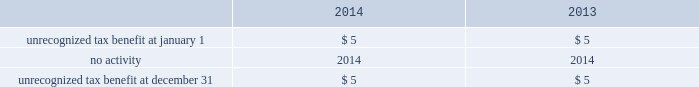Table of contents notes to consolidated financial statements of american airlines , inc .
American files its tax returns as prescribed by the tax laws of the jurisdictions in which it operates .
American 2019s 2004 through 2013 tax years are still subject to examination by the internal revenue service .
Various state and foreign jurisdiction tax years remain open to examination and american is under examination , in administrative appeals , or engaged in tax litigation in certain jurisdictions .
American believes that the effect of additional assessments will be immaterial to its consolidated financial statements .
American has an unrecognized tax benefit of approximately $ 5 million , which did not change during the twelve months ended december 31 , 2014 .
Changes in the unrecognized tax benefit have no impact on the effective tax rate due to the existence of the valuation allowance .
Accrued interest on tax positions is recorded as a component of interest expense but was not significant at december 31 , 2014 .
The reconciliation of the beginning and ending amounts of unrecognized tax benefit are ( in millions ) : .
American estimates that the unrecognized tax benefit will be realized within the next twelve months .
Risk management and financial instruments american 2019s economic prospects are heavily dependent upon two variables it cannot control : the health of the economy and the price of fuel .
Due to the discretionary nature of business and leisure travel spending , airline industry revenues are heavily influenced by the condition of the u.s .
Economy and economies in other regions of the world .
Unfavorable conditions in these broader economies have resulted , and may result in the future , in decreased passenger demand for air travel and changes in booking practices , both of which in turn have had , and may have in the future , a strong negative effect on american 2019s revenues .
In addition , during challenging economic times , actions by our competitors to increase their revenues can have an adverse impact on american 2019s revenues .
American 2019s operating results are materially impacted by changes in the availability , price volatility and cost of aircraft fuel , which represents one of the largest single cost items in american 2019s business .
Because of the amount of fuel needed to operate american 2019s business , even a relatively small increase in the price of fuel can have a material adverse aggregate effect on american 2019s operating results and liquidity .
Jet fuel market prices have fluctuated substantially over the past several years and prices continued to be volatile in 2014 .
These factors could impact american 2019s results of operations , financial performance and liquidity .
( a ) fuel price risk management during the second quarter of 2014 , american sold its portfolio of fuel hedging contracts that were scheduled to settle on or after june 30 , 2014 .
American has not entered into any transactions to hedge its fuel consumption since december 9 , 2013 and , accordingly , as of december 31 , 2014 , american did not have any fuel hedging contracts outstanding .
As such , and assuming american does not enter into any future transactions to hedge its fuel consumption , american will continue to be fully exposed to fluctuations in fuel prices .
American 2019s current policy is not to enter into transactions to hedge its fuel consumption , although american reviews that policy from time to time based on market conditions and other factors. .
What was the unrecognized tax benefit at december 31 , 2013? 
Computations: (5 * 1)
Answer: 5.0. 